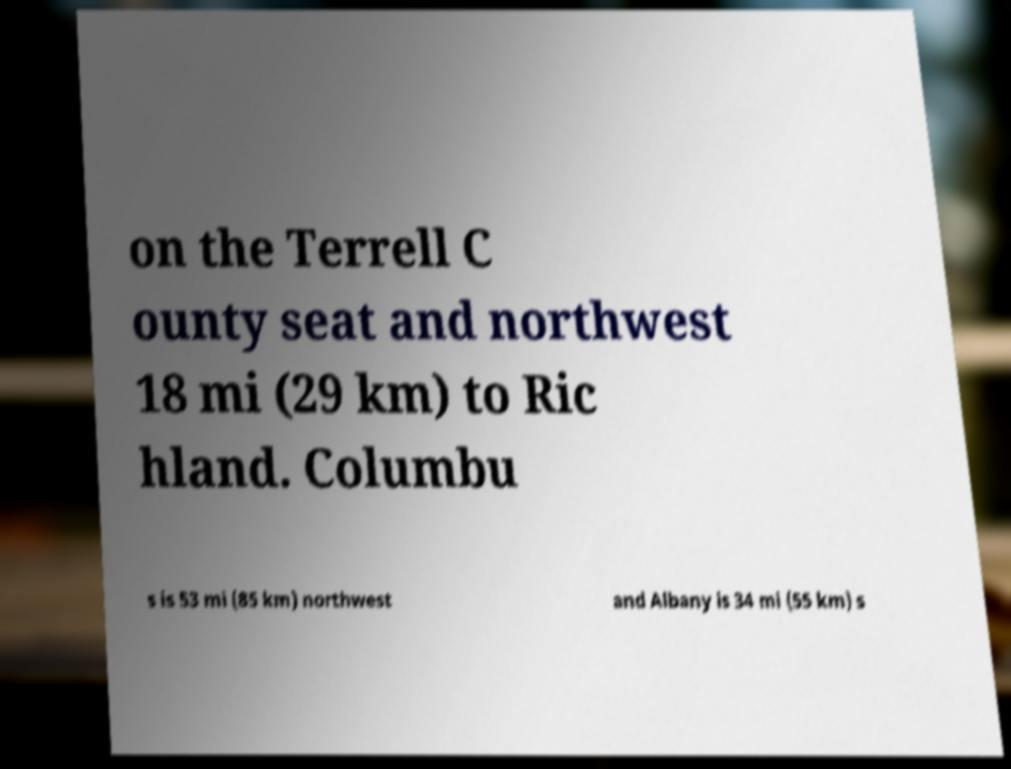Can you read and provide the text displayed in the image?This photo seems to have some interesting text. Can you extract and type it out for me? on the Terrell C ounty seat and northwest 18 mi (29 km) to Ric hland. Columbu s is 53 mi (85 km) northwest and Albany is 34 mi (55 km) s 